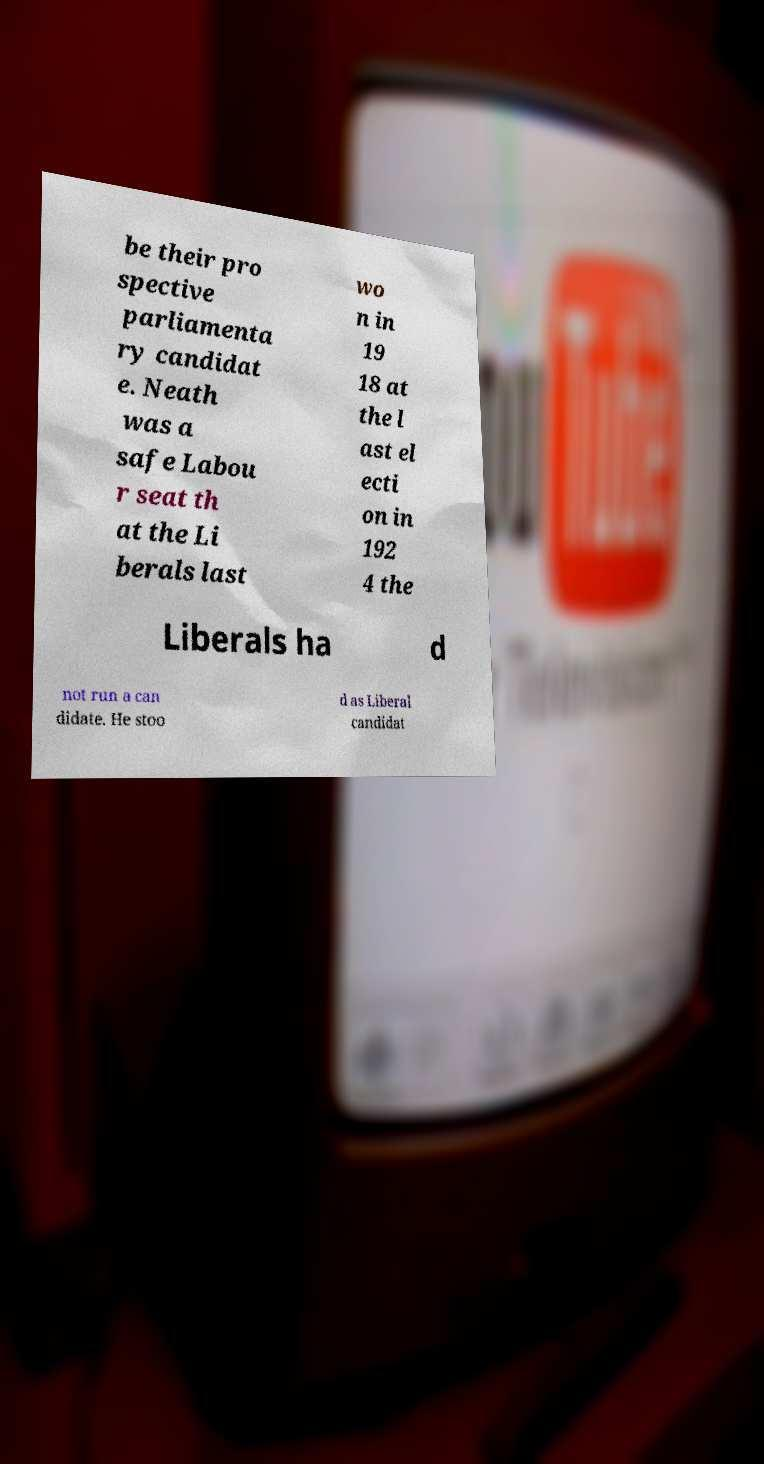Could you assist in decoding the text presented in this image and type it out clearly? be their pro spective parliamenta ry candidat e. Neath was a safe Labou r seat th at the Li berals last wo n in 19 18 at the l ast el ecti on in 192 4 the Liberals ha d not run a can didate. He stoo d as Liberal candidat 